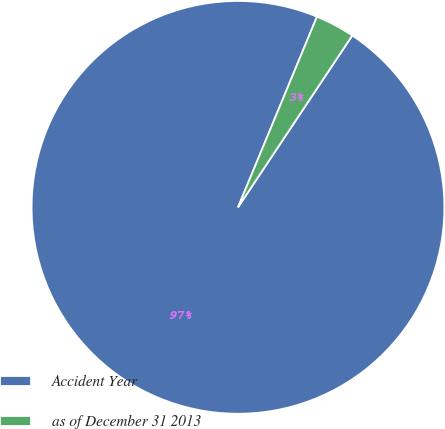<chart> <loc_0><loc_0><loc_500><loc_500><pie_chart><fcel>Accident Year<fcel>as of December 31 2013<nl><fcel>96.91%<fcel>3.09%<nl></chart> 